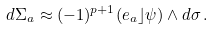Convert formula to latex. <formula><loc_0><loc_0><loc_500><loc_500>d \Sigma _ { a } \approx ( - 1 ) ^ { p + 1 } ( e _ { a } \rfloor \psi ) \wedge d \sigma \, .</formula> 